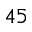<formula> <loc_0><loc_0><loc_500><loc_500>4 5</formula> 